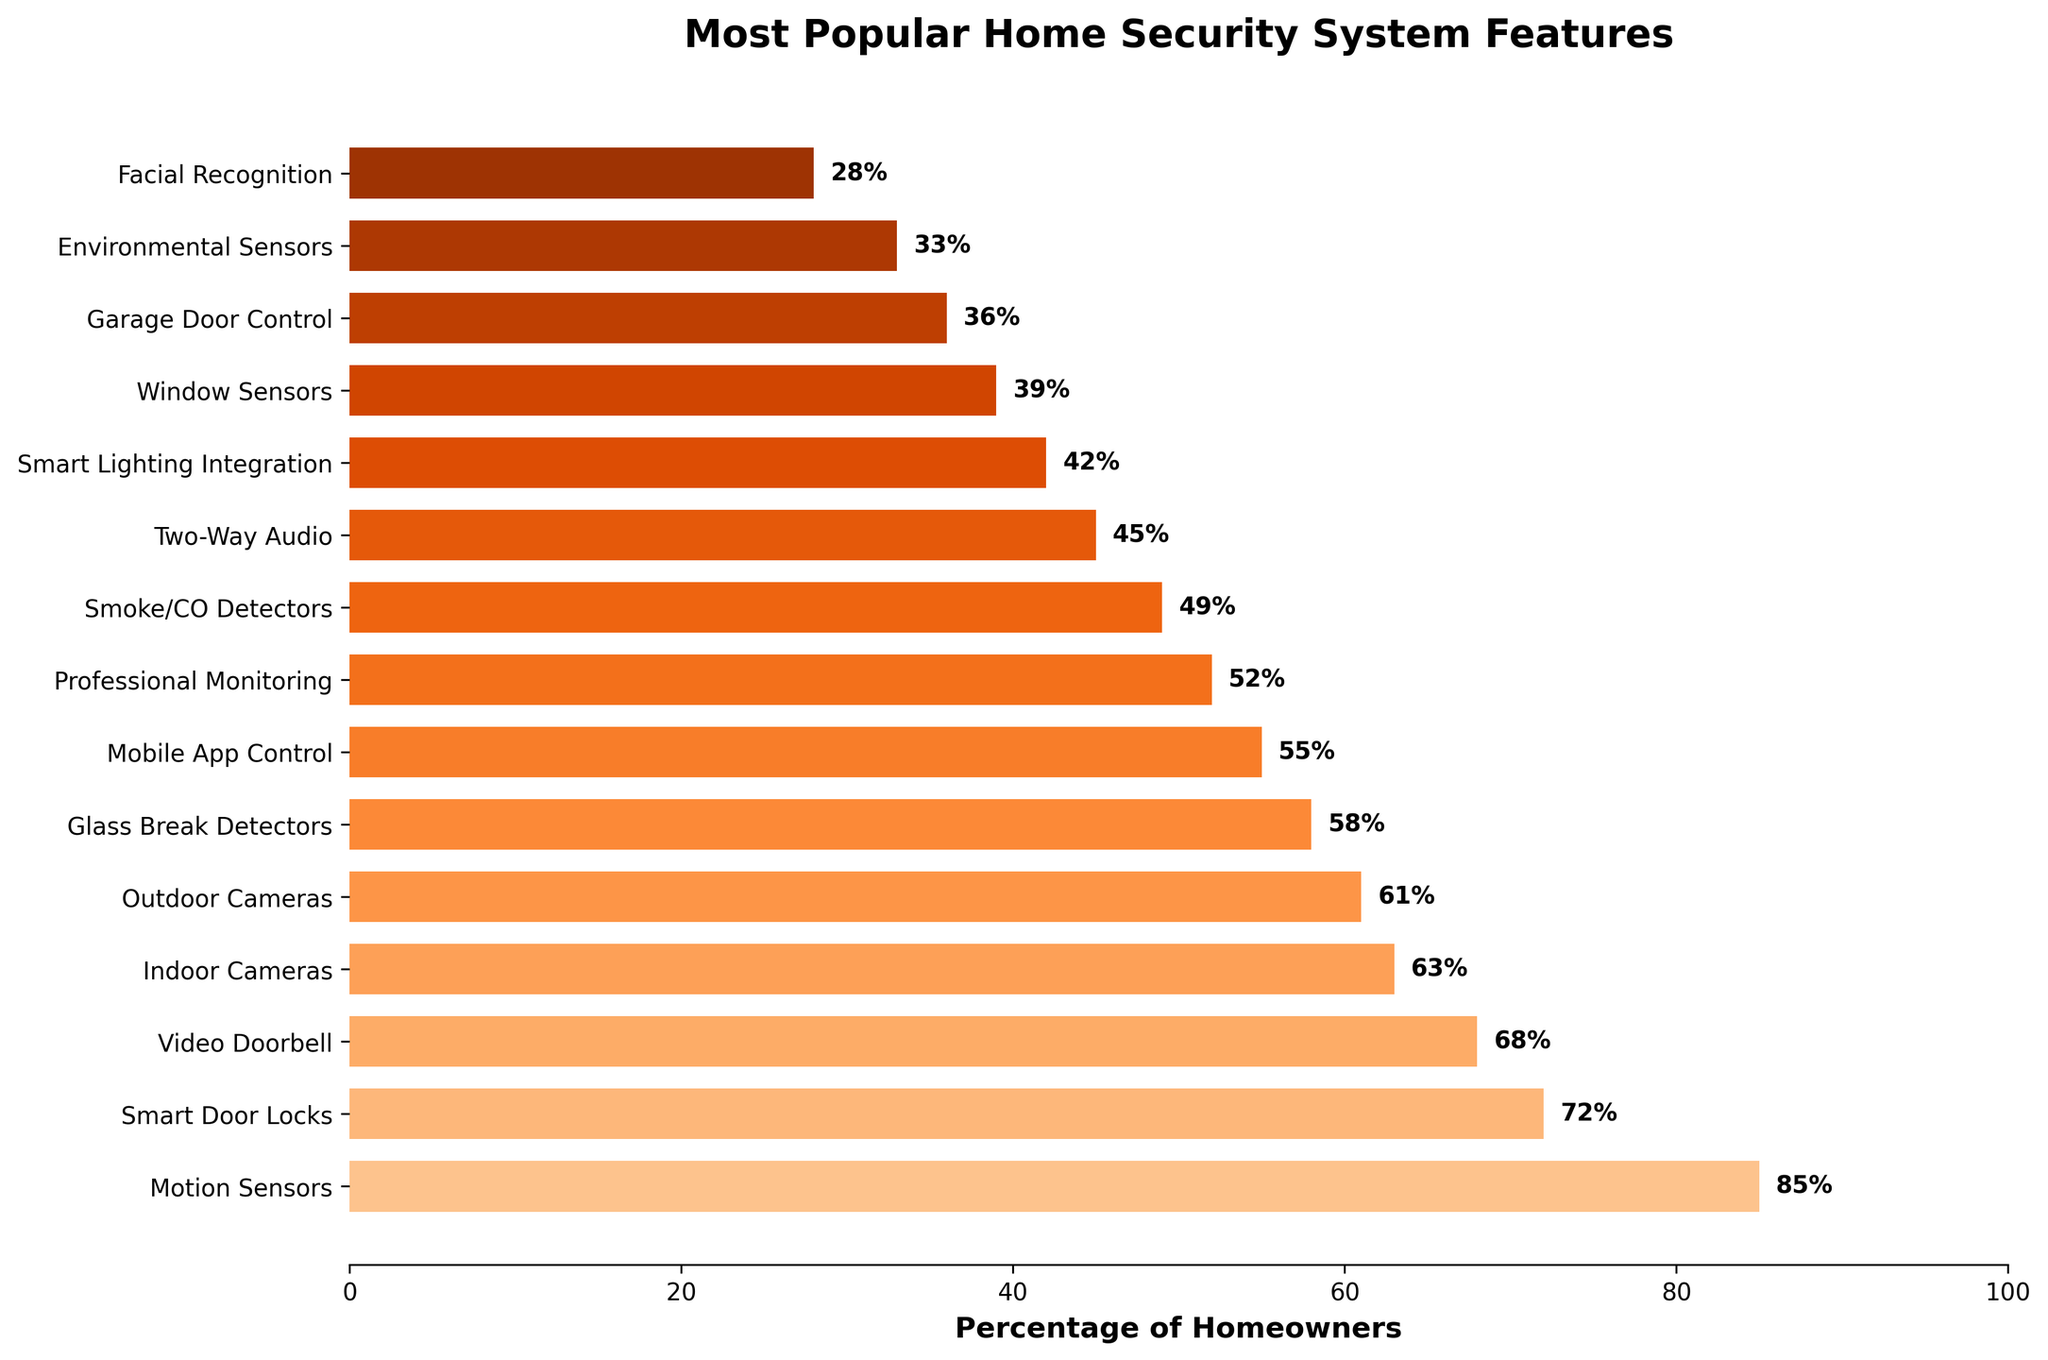Which feature is the most popular among homeowners? To find the most popular feature, look at the feature with the highest percentage value on the bar chart. The bar with the greatest length represents the most popular feature.
Answer: Motion Sensors How many features have a percentage of 50% or higher? Count the number of bars that extend beyond the 50% mark on the x-axis. These bars represent features with a percentage of 50% or higher.
Answer: 8 Which feature is preferred more: Indoor Cameras or Outdoor Cameras? Compare the lengths of the bars corresponding to Indoor Cameras and Outdoor Cameras. The bar with a greater length indicates the more preferred feature.
Answer: Indoor Cameras What is the difference in the percentage between the most and least popular features? Identify the highest and lowest percentage values and subtract the lower value from the higher value. Here, it's 85% (Motion Sensors) minus 28% (Facial Recognition).
Answer: 57% Are there any features with the same percentage? Check if any two bars on the chart extend to exactly the same length, which would indicate equal percentage values.
Answer: No What is the total percentage of homeowners who prefer Two-Way Audio, Smart Lighting Integration, and Window Sensors combined? Add the percentage values for Two-Way Audio (45%), Smart Lighting Integration (42%), and Window Sensors (39%).
Answer: 126% Which is preferred more by homeowners: Professional Monitoring or Mobile App Control? Compare the lengths of the bars for Professional Monitoring and Mobile App Control. The longer bar indicates the more preferred feature.
Answer: Mobile App Control Is the percentage of homeowners who prefer Garage Door Control higher or lower than those who prefer Smoke/CO Detectors? Compare the lengths of the bars for Garage Door Control and Smoke/CO Detectors to determine which is higher.
Answer: Lower How many features have percentages between 40% and 60%? Count the bars that fall within the range of 40% to 60%, inclusive.
Answer: 4 What is the percentage difference between homeowners preferring Smart Door Locks versus Video Doorbell? Subtract the percentage for Video Doorbell (68%) from that for Smart Door Locks (72%).
Answer: 4% 